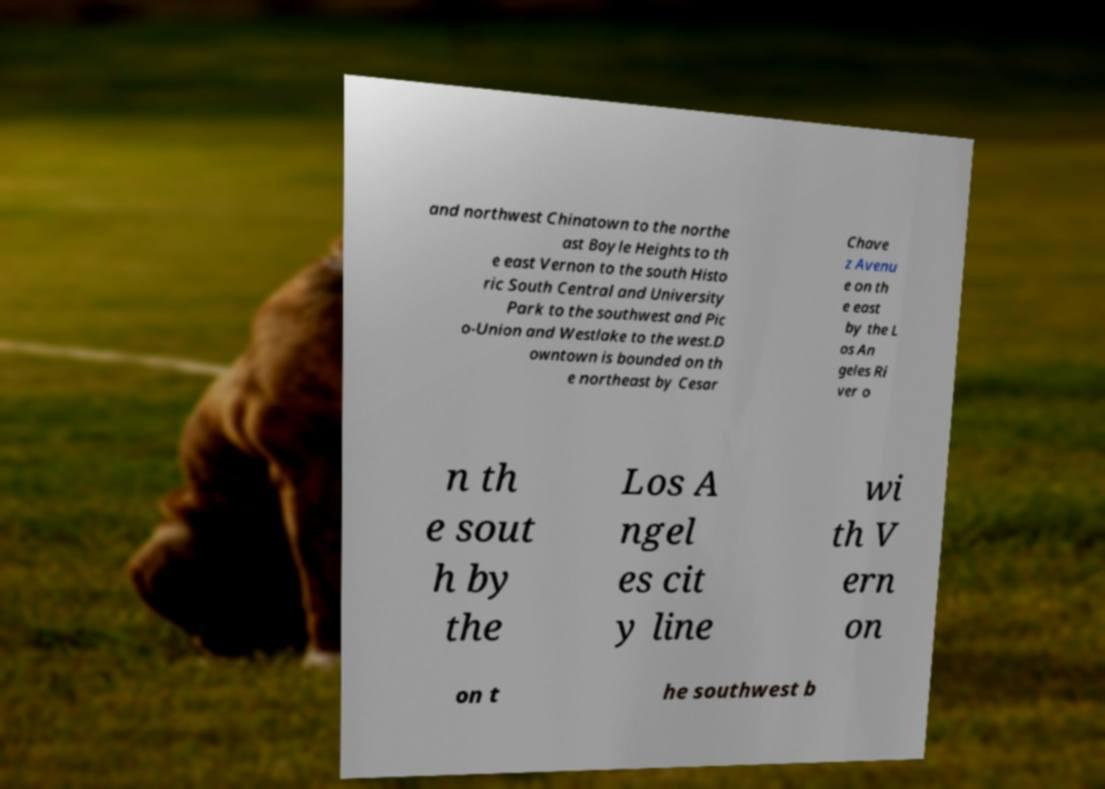Can you accurately transcribe the text from the provided image for me? and northwest Chinatown to the northe ast Boyle Heights to th e east Vernon to the south Histo ric South Central and University Park to the southwest and Pic o-Union and Westlake to the west.D owntown is bounded on th e northeast by Cesar Chave z Avenu e on th e east by the L os An geles Ri ver o n th e sout h by the Los A ngel es cit y line wi th V ern on on t he southwest b 